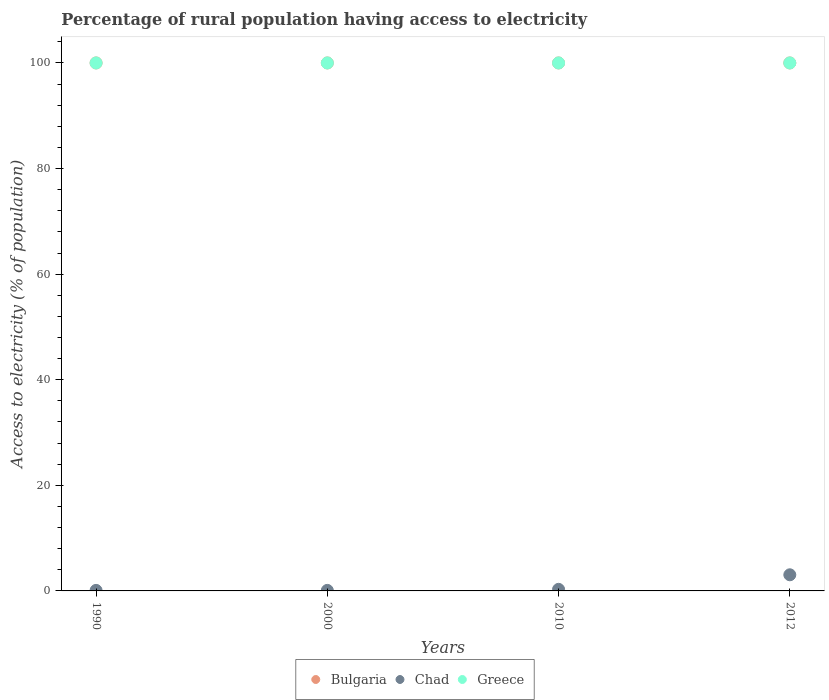How many different coloured dotlines are there?
Offer a very short reply. 3. Is the number of dotlines equal to the number of legend labels?
Offer a terse response. Yes. What is the percentage of rural population having access to electricity in Chad in 2012?
Your answer should be very brief. 3.05. Across all years, what is the maximum percentage of rural population having access to electricity in Bulgaria?
Keep it short and to the point. 100. Across all years, what is the minimum percentage of rural population having access to electricity in Greece?
Give a very brief answer. 100. In which year was the percentage of rural population having access to electricity in Chad maximum?
Provide a short and direct response. 2012. What is the total percentage of rural population having access to electricity in Greece in the graph?
Your response must be concise. 400. What is the difference between the percentage of rural population having access to electricity in Chad in 1990 and that in 2010?
Your answer should be compact. -0.2. In the year 2010, what is the difference between the percentage of rural population having access to electricity in Bulgaria and percentage of rural population having access to electricity in Chad?
Offer a very short reply. 99.7. What is the ratio of the percentage of rural population having access to electricity in Greece in 1990 to that in 2012?
Make the answer very short. 1. What is the difference between the highest and the second highest percentage of rural population having access to electricity in Bulgaria?
Provide a succinct answer. 0. Is the percentage of rural population having access to electricity in Bulgaria strictly less than the percentage of rural population having access to electricity in Greece over the years?
Offer a very short reply. No. How many dotlines are there?
Your answer should be very brief. 3. How many years are there in the graph?
Provide a short and direct response. 4. What is the difference between two consecutive major ticks on the Y-axis?
Keep it short and to the point. 20. Does the graph contain any zero values?
Give a very brief answer. No. How many legend labels are there?
Your answer should be compact. 3. What is the title of the graph?
Your response must be concise. Percentage of rural population having access to electricity. Does "Mali" appear as one of the legend labels in the graph?
Provide a succinct answer. No. What is the label or title of the X-axis?
Give a very brief answer. Years. What is the label or title of the Y-axis?
Your answer should be compact. Access to electricity (% of population). What is the Access to electricity (% of population) in Bulgaria in 1990?
Your answer should be compact. 100. What is the Access to electricity (% of population) in Greece in 1990?
Give a very brief answer. 100. What is the Access to electricity (% of population) of Bulgaria in 2010?
Your response must be concise. 100. What is the Access to electricity (% of population) of Bulgaria in 2012?
Make the answer very short. 100. What is the Access to electricity (% of population) of Chad in 2012?
Ensure brevity in your answer.  3.05. What is the Access to electricity (% of population) in Greece in 2012?
Your answer should be compact. 100. Across all years, what is the maximum Access to electricity (% of population) in Bulgaria?
Provide a short and direct response. 100. Across all years, what is the maximum Access to electricity (% of population) in Chad?
Your answer should be very brief. 3.05. Across all years, what is the maximum Access to electricity (% of population) of Greece?
Give a very brief answer. 100. What is the total Access to electricity (% of population) of Bulgaria in the graph?
Offer a very short reply. 400. What is the total Access to electricity (% of population) of Chad in the graph?
Provide a succinct answer. 3.55. What is the total Access to electricity (% of population) of Greece in the graph?
Ensure brevity in your answer.  400. What is the difference between the Access to electricity (% of population) in Bulgaria in 1990 and that in 2010?
Make the answer very short. 0. What is the difference between the Access to electricity (% of population) in Chad in 1990 and that in 2010?
Provide a short and direct response. -0.2. What is the difference between the Access to electricity (% of population) of Bulgaria in 1990 and that in 2012?
Your response must be concise. 0. What is the difference between the Access to electricity (% of population) of Chad in 1990 and that in 2012?
Provide a short and direct response. -2.95. What is the difference between the Access to electricity (% of population) of Greece in 2000 and that in 2010?
Keep it short and to the point. 0. What is the difference between the Access to electricity (% of population) in Chad in 2000 and that in 2012?
Give a very brief answer. -2.95. What is the difference between the Access to electricity (% of population) of Greece in 2000 and that in 2012?
Provide a succinct answer. 0. What is the difference between the Access to electricity (% of population) in Chad in 2010 and that in 2012?
Give a very brief answer. -2.75. What is the difference between the Access to electricity (% of population) of Greece in 2010 and that in 2012?
Provide a short and direct response. 0. What is the difference between the Access to electricity (% of population) of Bulgaria in 1990 and the Access to electricity (% of population) of Chad in 2000?
Give a very brief answer. 99.9. What is the difference between the Access to electricity (% of population) in Bulgaria in 1990 and the Access to electricity (% of population) in Greece in 2000?
Ensure brevity in your answer.  0. What is the difference between the Access to electricity (% of population) in Chad in 1990 and the Access to electricity (% of population) in Greece in 2000?
Give a very brief answer. -99.9. What is the difference between the Access to electricity (% of population) of Bulgaria in 1990 and the Access to electricity (% of population) of Chad in 2010?
Keep it short and to the point. 99.7. What is the difference between the Access to electricity (% of population) in Bulgaria in 1990 and the Access to electricity (% of population) in Greece in 2010?
Keep it short and to the point. 0. What is the difference between the Access to electricity (% of population) in Chad in 1990 and the Access to electricity (% of population) in Greece in 2010?
Your answer should be very brief. -99.9. What is the difference between the Access to electricity (% of population) of Bulgaria in 1990 and the Access to electricity (% of population) of Chad in 2012?
Keep it short and to the point. 96.95. What is the difference between the Access to electricity (% of population) of Chad in 1990 and the Access to electricity (% of population) of Greece in 2012?
Your response must be concise. -99.9. What is the difference between the Access to electricity (% of population) of Bulgaria in 2000 and the Access to electricity (% of population) of Chad in 2010?
Your answer should be very brief. 99.7. What is the difference between the Access to electricity (% of population) of Chad in 2000 and the Access to electricity (% of population) of Greece in 2010?
Provide a short and direct response. -99.9. What is the difference between the Access to electricity (% of population) of Bulgaria in 2000 and the Access to electricity (% of population) of Chad in 2012?
Offer a very short reply. 96.95. What is the difference between the Access to electricity (% of population) in Bulgaria in 2000 and the Access to electricity (% of population) in Greece in 2012?
Your response must be concise. 0. What is the difference between the Access to electricity (% of population) of Chad in 2000 and the Access to electricity (% of population) of Greece in 2012?
Offer a very short reply. -99.9. What is the difference between the Access to electricity (% of population) of Bulgaria in 2010 and the Access to electricity (% of population) of Chad in 2012?
Your response must be concise. 96.95. What is the difference between the Access to electricity (% of population) in Bulgaria in 2010 and the Access to electricity (% of population) in Greece in 2012?
Your answer should be compact. 0. What is the difference between the Access to electricity (% of population) in Chad in 2010 and the Access to electricity (% of population) in Greece in 2012?
Provide a succinct answer. -99.7. What is the average Access to electricity (% of population) in Chad per year?
Offer a very short reply. 0.89. What is the average Access to electricity (% of population) of Greece per year?
Provide a succinct answer. 100. In the year 1990, what is the difference between the Access to electricity (% of population) of Bulgaria and Access to electricity (% of population) of Chad?
Make the answer very short. 99.9. In the year 1990, what is the difference between the Access to electricity (% of population) in Chad and Access to electricity (% of population) in Greece?
Your answer should be compact. -99.9. In the year 2000, what is the difference between the Access to electricity (% of population) in Bulgaria and Access to electricity (% of population) in Chad?
Make the answer very short. 99.9. In the year 2000, what is the difference between the Access to electricity (% of population) of Bulgaria and Access to electricity (% of population) of Greece?
Provide a short and direct response. 0. In the year 2000, what is the difference between the Access to electricity (% of population) in Chad and Access to electricity (% of population) in Greece?
Keep it short and to the point. -99.9. In the year 2010, what is the difference between the Access to electricity (% of population) of Bulgaria and Access to electricity (% of population) of Chad?
Give a very brief answer. 99.7. In the year 2010, what is the difference between the Access to electricity (% of population) in Chad and Access to electricity (% of population) in Greece?
Give a very brief answer. -99.7. In the year 2012, what is the difference between the Access to electricity (% of population) in Bulgaria and Access to electricity (% of population) in Chad?
Offer a terse response. 96.95. In the year 2012, what is the difference between the Access to electricity (% of population) of Bulgaria and Access to electricity (% of population) of Greece?
Your response must be concise. 0. In the year 2012, what is the difference between the Access to electricity (% of population) of Chad and Access to electricity (% of population) of Greece?
Provide a succinct answer. -96.95. What is the ratio of the Access to electricity (% of population) of Bulgaria in 1990 to that in 2000?
Give a very brief answer. 1. What is the ratio of the Access to electricity (% of population) of Chad in 1990 to that in 2000?
Give a very brief answer. 1. What is the ratio of the Access to electricity (% of population) in Bulgaria in 1990 to that in 2012?
Keep it short and to the point. 1. What is the ratio of the Access to electricity (% of population) in Chad in 1990 to that in 2012?
Ensure brevity in your answer.  0.03. What is the ratio of the Access to electricity (% of population) of Chad in 2000 to that in 2010?
Your answer should be very brief. 0.33. What is the ratio of the Access to electricity (% of population) of Greece in 2000 to that in 2010?
Ensure brevity in your answer.  1. What is the ratio of the Access to electricity (% of population) in Bulgaria in 2000 to that in 2012?
Offer a terse response. 1. What is the ratio of the Access to electricity (% of population) in Chad in 2000 to that in 2012?
Your response must be concise. 0.03. What is the ratio of the Access to electricity (% of population) of Chad in 2010 to that in 2012?
Your answer should be very brief. 0.1. What is the difference between the highest and the second highest Access to electricity (% of population) in Chad?
Make the answer very short. 2.75. What is the difference between the highest and the second highest Access to electricity (% of population) in Greece?
Offer a very short reply. 0. What is the difference between the highest and the lowest Access to electricity (% of population) in Bulgaria?
Ensure brevity in your answer.  0. What is the difference between the highest and the lowest Access to electricity (% of population) of Chad?
Make the answer very short. 2.95. What is the difference between the highest and the lowest Access to electricity (% of population) in Greece?
Your answer should be compact. 0. 